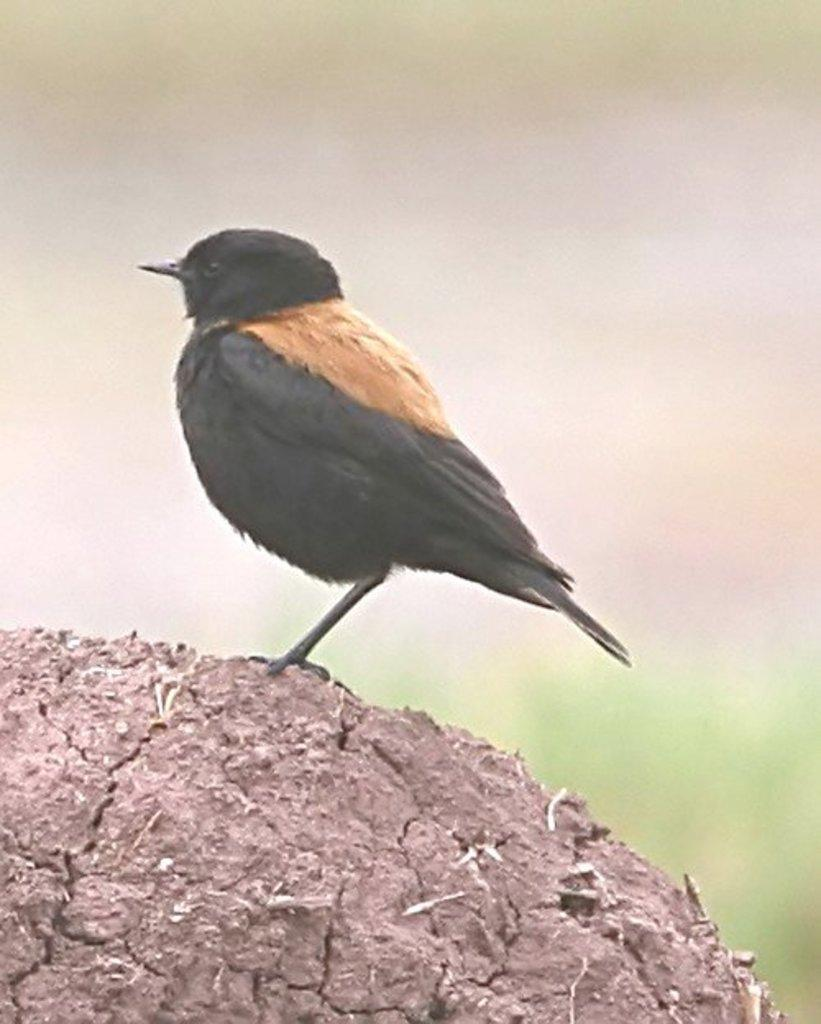What is the main subject of the image? There is a bird in the image. Where is the bird located in the image? The bird is in the center of the image. What type of surface is the bird on? The bird is on a muddy texture. What type of card is the bird holding in the image? A: There is no card present in the image, and the bird is not holding anything. 